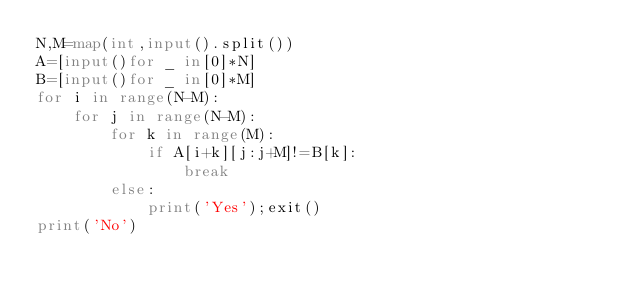<code> <loc_0><loc_0><loc_500><loc_500><_Python_>N,M=map(int,input().split())
A=[input()for _ in[0]*N]
B=[input()for _ in[0]*M]
for i in range(N-M):
    for j in range(N-M):
        for k in range(M):
            if A[i+k][j:j+M]!=B[k]:
                break
        else:
            print('Yes');exit()
print('No')</code> 